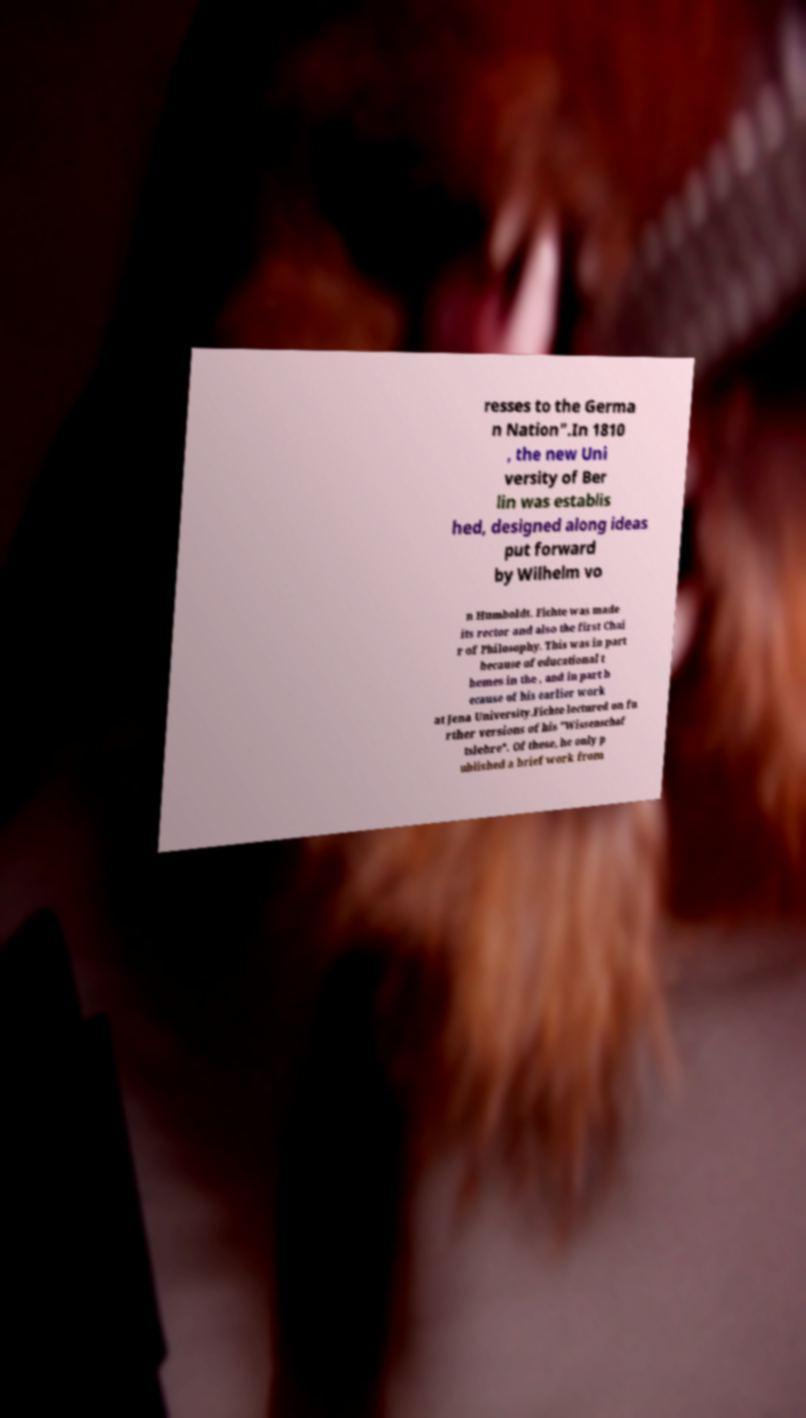Could you assist in decoding the text presented in this image and type it out clearly? resses to the Germa n Nation".In 1810 , the new Uni versity of Ber lin was establis hed, designed along ideas put forward by Wilhelm vo n Humboldt. Fichte was made its rector and also the first Chai r of Philosophy. This was in part because of educational t hemes in the , and in part b ecause of his earlier work at Jena University.Fichte lectured on fu rther versions of his "Wissenschaf tslehre". Of these, he only p ublished a brief work from 